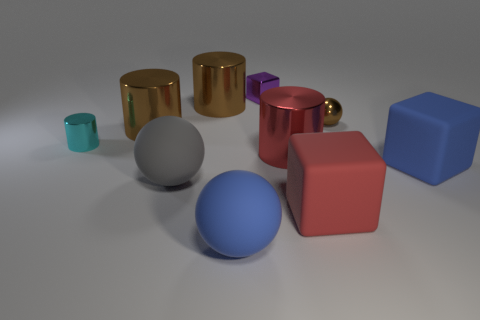The brown metallic thing to the right of the purple shiny object has what shape?
Your answer should be compact. Sphere. Is the red shiny object the same shape as the small brown thing?
Your response must be concise. No. Are there the same number of large blue matte cubes left of the tiny shiny cylinder and yellow cylinders?
Give a very brief answer. Yes. What shape is the small cyan metal object?
Provide a succinct answer. Cylinder. Is there any other thing that has the same color as the small metal block?
Your answer should be compact. No. Do the blue thing that is to the right of the shiny block and the ball that is behind the gray rubber thing have the same size?
Your answer should be compact. No. There is a large blue object on the right side of the shiny cylinder that is in front of the cyan thing; what shape is it?
Your response must be concise. Cube. Is the size of the red shiny cylinder the same as the sphere behind the tiny cyan thing?
Provide a succinct answer. No. There is a blue matte object that is in front of the block that is in front of the blue matte thing that is to the right of the large red block; what size is it?
Your answer should be very brief. Large. What number of things are either blue rubber objects that are in front of the gray ball or small cyan cylinders?
Keep it short and to the point. 2. 